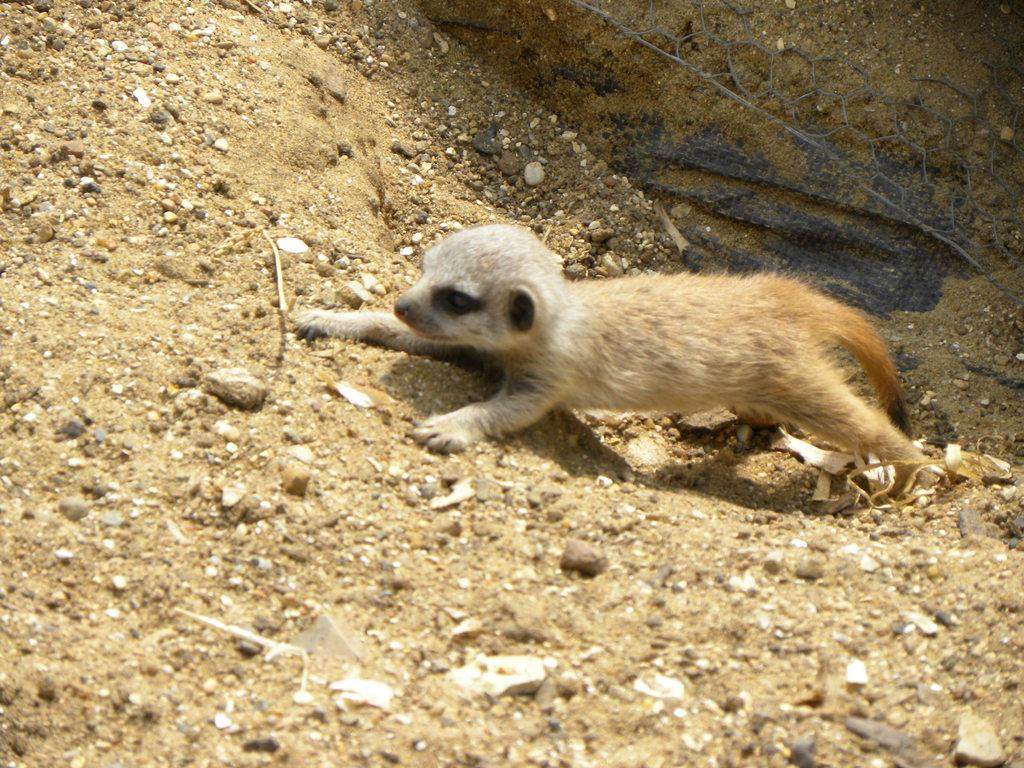What animal is in the foreground of the image? There is a meerkat in the foreground of the image. What is the position of the meerkat in the image? The meerkat is on the ground. What can be seen in the top right corner of the image? There is a metal mesh and a black colored cloth in the top right corner of the image. What arithmetic problem is the meerkat solving in the image? The image does not depict the meerkat solving any arithmetic problem; it is simply standing on the ground. What type of fiction is the meerkat reading in the image? There is no book or any form of fiction present in the image; it only features a meerkat standing on the ground and a metal mesh with a black colored cloth in the top right corner. 